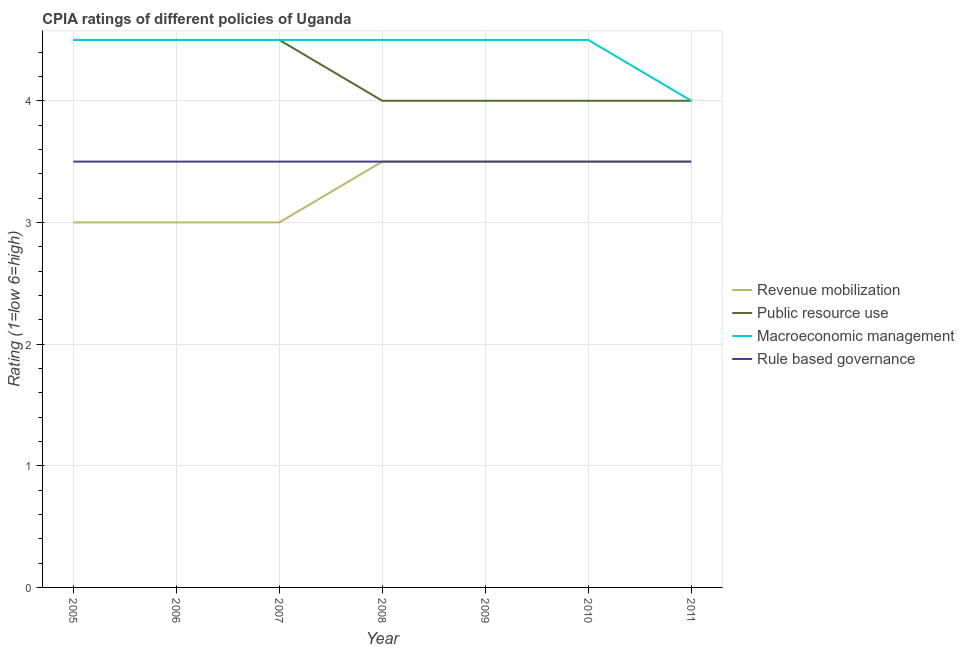How many different coloured lines are there?
Your answer should be compact. 4. Is the number of lines equal to the number of legend labels?
Your response must be concise. Yes. What is the cpia rating of revenue mobilization in 2005?
Provide a short and direct response. 3. In which year was the cpia rating of revenue mobilization minimum?
Ensure brevity in your answer.  2005. What is the total cpia rating of revenue mobilization in the graph?
Provide a succinct answer. 23. What is the difference between the cpia rating of public resource use in 2005 and that in 2008?
Offer a very short reply. 0.5. What is the difference between the cpia rating of macroeconomic management in 2005 and the cpia rating of public resource use in 2010?
Give a very brief answer. 0.5. What is the average cpia rating of macroeconomic management per year?
Provide a short and direct response. 4.43. Is the cpia rating of revenue mobilization in 2005 less than that in 2008?
Provide a short and direct response. Yes. Is the difference between the cpia rating of revenue mobilization in 2007 and 2009 greater than the difference between the cpia rating of public resource use in 2007 and 2009?
Ensure brevity in your answer.  No. Is it the case that in every year, the sum of the cpia rating of revenue mobilization and cpia rating of public resource use is greater than the cpia rating of macroeconomic management?
Offer a terse response. Yes. Does the cpia rating of revenue mobilization monotonically increase over the years?
Your answer should be compact. No. Is the cpia rating of public resource use strictly greater than the cpia rating of revenue mobilization over the years?
Provide a succinct answer. Yes. Is the cpia rating of rule based governance strictly less than the cpia rating of public resource use over the years?
Your response must be concise. Yes. How many lines are there?
Your answer should be very brief. 4. How many years are there in the graph?
Keep it short and to the point. 7. Does the graph contain any zero values?
Make the answer very short. No. How many legend labels are there?
Offer a very short reply. 4. What is the title of the graph?
Ensure brevity in your answer.  CPIA ratings of different policies of Uganda. Does "Business regulatory environment" appear as one of the legend labels in the graph?
Make the answer very short. No. What is the label or title of the Y-axis?
Your answer should be compact. Rating (1=low 6=high). What is the Rating (1=low 6=high) of Revenue mobilization in 2005?
Your response must be concise. 3. What is the Rating (1=low 6=high) of Public resource use in 2005?
Make the answer very short. 4.5. What is the Rating (1=low 6=high) of Macroeconomic management in 2005?
Your answer should be very brief. 4.5. What is the Rating (1=low 6=high) in Public resource use in 2006?
Give a very brief answer. 4.5. What is the Rating (1=low 6=high) of Macroeconomic management in 2006?
Ensure brevity in your answer.  4.5. What is the Rating (1=low 6=high) of Macroeconomic management in 2007?
Offer a very short reply. 4.5. What is the Rating (1=low 6=high) in Rule based governance in 2007?
Your response must be concise. 3.5. What is the Rating (1=low 6=high) of Revenue mobilization in 2008?
Offer a very short reply. 3.5. What is the Rating (1=low 6=high) in Macroeconomic management in 2008?
Provide a short and direct response. 4.5. What is the Rating (1=low 6=high) of Revenue mobilization in 2009?
Your response must be concise. 3.5. What is the Rating (1=low 6=high) in Revenue mobilization in 2010?
Provide a short and direct response. 3.5. What is the Rating (1=low 6=high) in Public resource use in 2010?
Provide a succinct answer. 4. What is the Rating (1=low 6=high) in Rule based governance in 2010?
Give a very brief answer. 3.5. What is the Rating (1=low 6=high) in Revenue mobilization in 2011?
Offer a very short reply. 3.5. What is the Rating (1=low 6=high) in Public resource use in 2011?
Your answer should be compact. 4. What is the Rating (1=low 6=high) of Macroeconomic management in 2011?
Ensure brevity in your answer.  4. What is the Rating (1=low 6=high) in Rule based governance in 2011?
Keep it short and to the point. 3.5. Across all years, what is the maximum Rating (1=low 6=high) of Revenue mobilization?
Provide a short and direct response. 3.5. Across all years, what is the maximum Rating (1=low 6=high) in Public resource use?
Provide a succinct answer. 4.5. Across all years, what is the maximum Rating (1=low 6=high) of Macroeconomic management?
Your answer should be compact. 4.5. What is the total Rating (1=low 6=high) of Public resource use in the graph?
Offer a terse response. 29.5. What is the total Rating (1=low 6=high) in Rule based governance in the graph?
Provide a short and direct response. 24.5. What is the difference between the Rating (1=low 6=high) in Revenue mobilization in 2005 and that in 2006?
Keep it short and to the point. 0. What is the difference between the Rating (1=low 6=high) in Macroeconomic management in 2005 and that in 2006?
Offer a terse response. 0. What is the difference between the Rating (1=low 6=high) of Revenue mobilization in 2005 and that in 2007?
Offer a terse response. 0. What is the difference between the Rating (1=low 6=high) of Public resource use in 2005 and that in 2007?
Your response must be concise. 0. What is the difference between the Rating (1=low 6=high) of Macroeconomic management in 2005 and that in 2007?
Your answer should be compact. 0. What is the difference between the Rating (1=low 6=high) in Revenue mobilization in 2005 and that in 2008?
Ensure brevity in your answer.  -0.5. What is the difference between the Rating (1=low 6=high) of Public resource use in 2005 and that in 2008?
Make the answer very short. 0.5. What is the difference between the Rating (1=low 6=high) in Macroeconomic management in 2005 and that in 2008?
Your response must be concise. 0. What is the difference between the Rating (1=low 6=high) of Rule based governance in 2005 and that in 2008?
Your response must be concise. 0. What is the difference between the Rating (1=low 6=high) of Revenue mobilization in 2005 and that in 2009?
Your answer should be compact. -0.5. What is the difference between the Rating (1=low 6=high) in Public resource use in 2005 and that in 2009?
Offer a very short reply. 0.5. What is the difference between the Rating (1=low 6=high) in Macroeconomic management in 2005 and that in 2010?
Your response must be concise. 0. What is the difference between the Rating (1=low 6=high) of Rule based governance in 2005 and that in 2010?
Provide a short and direct response. 0. What is the difference between the Rating (1=low 6=high) of Macroeconomic management in 2005 and that in 2011?
Offer a terse response. 0.5. What is the difference between the Rating (1=low 6=high) in Public resource use in 2006 and that in 2007?
Your answer should be very brief. 0. What is the difference between the Rating (1=low 6=high) in Macroeconomic management in 2006 and that in 2007?
Make the answer very short. 0. What is the difference between the Rating (1=low 6=high) of Rule based governance in 2006 and that in 2007?
Keep it short and to the point. 0. What is the difference between the Rating (1=low 6=high) in Revenue mobilization in 2006 and that in 2008?
Provide a short and direct response. -0.5. What is the difference between the Rating (1=low 6=high) of Public resource use in 2006 and that in 2008?
Give a very brief answer. 0.5. What is the difference between the Rating (1=low 6=high) of Rule based governance in 2006 and that in 2008?
Your response must be concise. 0. What is the difference between the Rating (1=low 6=high) in Revenue mobilization in 2006 and that in 2009?
Provide a succinct answer. -0.5. What is the difference between the Rating (1=low 6=high) of Rule based governance in 2006 and that in 2010?
Provide a succinct answer. 0. What is the difference between the Rating (1=low 6=high) in Revenue mobilization in 2006 and that in 2011?
Ensure brevity in your answer.  -0.5. What is the difference between the Rating (1=low 6=high) of Macroeconomic management in 2007 and that in 2008?
Offer a very short reply. 0. What is the difference between the Rating (1=low 6=high) in Rule based governance in 2007 and that in 2008?
Your answer should be very brief. 0. What is the difference between the Rating (1=low 6=high) of Revenue mobilization in 2007 and that in 2010?
Make the answer very short. -0.5. What is the difference between the Rating (1=low 6=high) in Macroeconomic management in 2007 and that in 2010?
Ensure brevity in your answer.  0. What is the difference between the Rating (1=low 6=high) of Rule based governance in 2007 and that in 2010?
Provide a short and direct response. 0. What is the difference between the Rating (1=low 6=high) in Public resource use in 2007 and that in 2011?
Your response must be concise. 0.5. What is the difference between the Rating (1=low 6=high) in Revenue mobilization in 2008 and that in 2009?
Give a very brief answer. 0. What is the difference between the Rating (1=low 6=high) of Public resource use in 2008 and that in 2009?
Your answer should be very brief. 0. What is the difference between the Rating (1=low 6=high) of Revenue mobilization in 2008 and that in 2010?
Provide a short and direct response. 0. What is the difference between the Rating (1=low 6=high) of Public resource use in 2008 and that in 2010?
Keep it short and to the point. 0. What is the difference between the Rating (1=low 6=high) of Rule based governance in 2008 and that in 2010?
Your answer should be very brief. 0. What is the difference between the Rating (1=low 6=high) in Public resource use in 2009 and that in 2010?
Your response must be concise. 0. What is the difference between the Rating (1=low 6=high) in Macroeconomic management in 2009 and that in 2010?
Keep it short and to the point. 0. What is the difference between the Rating (1=low 6=high) in Rule based governance in 2009 and that in 2011?
Provide a succinct answer. 0. What is the difference between the Rating (1=low 6=high) in Rule based governance in 2010 and that in 2011?
Ensure brevity in your answer.  0. What is the difference between the Rating (1=low 6=high) of Revenue mobilization in 2005 and the Rating (1=low 6=high) of Macroeconomic management in 2006?
Provide a succinct answer. -1.5. What is the difference between the Rating (1=low 6=high) in Public resource use in 2005 and the Rating (1=low 6=high) in Rule based governance in 2006?
Provide a short and direct response. 1. What is the difference between the Rating (1=low 6=high) of Public resource use in 2005 and the Rating (1=low 6=high) of Rule based governance in 2007?
Offer a very short reply. 1. What is the difference between the Rating (1=low 6=high) in Revenue mobilization in 2005 and the Rating (1=low 6=high) in Public resource use in 2008?
Provide a succinct answer. -1. What is the difference between the Rating (1=low 6=high) of Revenue mobilization in 2005 and the Rating (1=low 6=high) of Macroeconomic management in 2008?
Offer a very short reply. -1.5. What is the difference between the Rating (1=low 6=high) in Public resource use in 2005 and the Rating (1=low 6=high) in Rule based governance in 2008?
Give a very brief answer. 1. What is the difference between the Rating (1=low 6=high) of Revenue mobilization in 2005 and the Rating (1=low 6=high) of Rule based governance in 2009?
Offer a terse response. -0.5. What is the difference between the Rating (1=low 6=high) of Public resource use in 2005 and the Rating (1=low 6=high) of Rule based governance in 2009?
Give a very brief answer. 1. What is the difference between the Rating (1=low 6=high) of Macroeconomic management in 2005 and the Rating (1=low 6=high) of Rule based governance in 2009?
Your answer should be very brief. 1. What is the difference between the Rating (1=low 6=high) of Revenue mobilization in 2005 and the Rating (1=low 6=high) of Public resource use in 2010?
Provide a succinct answer. -1. What is the difference between the Rating (1=low 6=high) in Public resource use in 2005 and the Rating (1=low 6=high) in Rule based governance in 2010?
Your answer should be very brief. 1. What is the difference between the Rating (1=low 6=high) in Revenue mobilization in 2005 and the Rating (1=low 6=high) in Public resource use in 2011?
Provide a short and direct response. -1. What is the difference between the Rating (1=low 6=high) in Revenue mobilization in 2005 and the Rating (1=low 6=high) in Macroeconomic management in 2011?
Give a very brief answer. -1. What is the difference between the Rating (1=low 6=high) in Revenue mobilization in 2005 and the Rating (1=low 6=high) in Rule based governance in 2011?
Make the answer very short. -0.5. What is the difference between the Rating (1=low 6=high) of Public resource use in 2005 and the Rating (1=low 6=high) of Macroeconomic management in 2011?
Your answer should be compact. 0.5. What is the difference between the Rating (1=low 6=high) in Public resource use in 2005 and the Rating (1=low 6=high) in Rule based governance in 2011?
Your answer should be compact. 1. What is the difference between the Rating (1=low 6=high) in Macroeconomic management in 2006 and the Rating (1=low 6=high) in Rule based governance in 2007?
Offer a very short reply. 1. What is the difference between the Rating (1=low 6=high) of Revenue mobilization in 2006 and the Rating (1=low 6=high) of Public resource use in 2008?
Your answer should be very brief. -1. What is the difference between the Rating (1=low 6=high) of Revenue mobilization in 2006 and the Rating (1=low 6=high) of Macroeconomic management in 2008?
Offer a terse response. -1.5. What is the difference between the Rating (1=low 6=high) of Revenue mobilization in 2006 and the Rating (1=low 6=high) of Rule based governance in 2008?
Offer a terse response. -0.5. What is the difference between the Rating (1=low 6=high) in Macroeconomic management in 2006 and the Rating (1=low 6=high) in Rule based governance in 2008?
Give a very brief answer. 1. What is the difference between the Rating (1=low 6=high) of Revenue mobilization in 2006 and the Rating (1=low 6=high) of Rule based governance in 2009?
Make the answer very short. -0.5. What is the difference between the Rating (1=low 6=high) in Public resource use in 2006 and the Rating (1=low 6=high) in Macroeconomic management in 2009?
Offer a terse response. 0. What is the difference between the Rating (1=low 6=high) of Revenue mobilization in 2006 and the Rating (1=low 6=high) of Public resource use in 2010?
Give a very brief answer. -1. What is the difference between the Rating (1=low 6=high) of Macroeconomic management in 2006 and the Rating (1=low 6=high) of Rule based governance in 2010?
Your answer should be very brief. 1. What is the difference between the Rating (1=low 6=high) in Public resource use in 2006 and the Rating (1=low 6=high) in Rule based governance in 2011?
Keep it short and to the point. 1. What is the difference between the Rating (1=low 6=high) of Macroeconomic management in 2006 and the Rating (1=low 6=high) of Rule based governance in 2011?
Provide a short and direct response. 1. What is the difference between the Rating (1=low 6=high) of Revenue mobilization in 2007 and the Rating (1=low 6=high) of Macroeconomic management in 2008?
Offer a very short reply. -1.5. What is the difference between the Rating (1=low 6=high) in Revenue mobilization in 2007 and the Rating (1=low 6=high) in Rule based governance in 2008?
Make the answer very short. -0.5. What is the difference between the Rating (1=low 6=high) in Public resource use in 2007 and the Rating (1=low 6=high) in Macroeconomic management in 2008?
Ensure brevity in your answer.  0. What is the difference between the Rating (1=low 6=high) in Public resource use in 2007 and the Rating (1=low 6=high) in Rule based governance in 2008?
Offer a very short reply. 1. What is the difference between the Rating (1=low 6=high) in Macroeconomic management in 2007 and the Rating (1=low 6=high) in Rule based governance in 2008?
Provide a succinct answer. 1. What is the difference between the Rating (1=low 6=high) of Revenue mobilization in 2007 and the Rating (1=low 6=high) of Macroeconomic management in 2009?
Offer a very short reply. -1.5. What is the difference between the Rating (1=low 6=high) in Public resource use in 2007 and the Rating (1=low 6=high) in Rule based governance in 2009?
Give a very brief answer. 1. What is the difference between the Rating (1=low 6=high) of Macroeconomic management in 2007 and the Rating (1=low 6=high) of Rule based governance in 2009?
Keep it short and to the point. 1. What is the difference between the Rating (1=low 6=high) of Revenue mobilization in 2007 and the Rating (1=low 6=high) of Macroeconomic management in 2010?
Your answer should be compact. -1.5. What is the difference between the Rating (1=low 6=high) in Public resource use in 2007 and the Rating (1=low 6=high) in Macroeconomic management in 2010?
Offer a very short reply. 0. What is the difference between the Rating (1=low 6=high) in Macroeconomic management in 2007 and the Rating (1=low 6=high) in Rule based governance in 2010?
Your answer should be very brief. 1. What is the difference between the Rating (1=low 6=high) in Revenue mobilization in 2007 and the Rating (1=low 6=high) in Public resource use in 2011?
Offer a terse response. -1. What is the difference between the Rating (1=low 6=high) of Revenue mobilization in 2007 and the Rating (1=low 6=high) of Macroeconomic management in 2011?
Keep it short and to the point. -1. What is the difference between the Rating (1=low 6=high) of Revenue mobilization in 2007 and the Rating (1=low 6=high) of Rule based governance in 2011?
Provide a succinct answer. -0.5. What is the difference between the Rating (1=low 6=high) of Public resource use in 2007 and the Rating (1=low 6=high) of Macroeconomic management in 2011?
Provide a short and direct response. 0.5. What is the difference between the Rating (1=low 6=high) of Macroeconomic management in 2007 and the Rating (1=low 6=high) of Rule based governance in 2011?
Give a very brief answer. 1. What is the difference between the Rating (1=low 6=high) of Public resource use in 2008 and the Rating (1=low 6=high) of Rule based governance in 2009?
Your response must be concise. 0.5. What is the difference between the Rating (1=low 6=high) in Macroeconomic management in 2008 and the Rating (1=low 6=high) in Rule based governance in 2009?
Make the answer very short. 1. What is the difference between the Rating (1=low 6=high) in Revenue mobilization in 2008 and the Rating (1=low 6=high) in Public resource use in 2010?
Provide a short and direct response. -0.5. What is the difference between the Rating (1=low 6=high) in Public resource use in 2008 and the Rating (1=low 6=high) in Macroeconomic management in 2010?
Make the answer very short. -0.5. What is the difference between the Rating (1=low 6=high) of Revenue mobilization in 2008 and the Rating (1=low 6=high) of Public resource use in 2011?
Ensure brevity in your answer.  -0.5. What is the difference between the Rating (1=low 6=high) of Public resource use in 2008 and the Rating (1=low 6=high) of Macroeconomic management in 2011?
Keep it short and to the point. 0. What is the difference between the Rating (1=low 6=high) of Macroeconomic management in 2008 and the Rating (1=low 6=high) of Rule based governance in 2011?
Your response must be concise. 1. What is the difference between the Rating (1=low 6=high) in Public resource use in 2009 and the Rating (1=low 6=high) in Macroeconomic management in 2010?
Keep it short and to the point. -0.5. What is the difference between the Rating (1=low 6=high) in Macroeconomic management in 2009 and the Rating (1=low 6=high) in Rule based governance in 2010?
Provide a short and direct response. 1. What is the difference between the Rating (1=low 6=high) in Revenue mobilization in 2009 and the Rating (1=low 6=high) in Macroeconomic management in 2011?
Offer a terse response. -0.5. What is the difference between the Rating (1=low 6=high) in Revenue mobilization in 2009 and the Rating (1=low 6=high) in Rule based governance in 2011?
Provide a short and direct response. 0. What is the difference between the Rating (1=low 6=high) in Revenue mobilization in 2010 and the Rating (1=low 6=high) in Macroeconomic management in 2011?
Offer a very short reply. -0.5. What is the difference between the Rating (1=low 6=high) of Public resource use in 2010 and the Rating (1=low 6=high) of Macroeconomic management in 2011?
Your response must be concise. 0. What is the average Rating (1=low 6=high) of Revenue mobilization per year?
Your response must be concise. 3.29. What is the average Rating (1=low 6=high) of Public resource use per year?
Provide a succinct answer. 4.21. What is the average Rating (1=low 6=high) in Macroeconomic management per year?
Offer a terse response. 4.43. In the year 2005, what is the difference between the Rating (1=low 6=high) of Revenue mobilization and Rating (1=low 6=high) of Public resource use?
Offer a very short reply. -1.5. In the year 2005, what is the difference between the Rating (1=low 6=high) of Revenue mobilization and Rating (1=low 6=high) of Macroeconomic management?
Provide a succinct answer. -1.5. In the year 2005, what is the difference between the Rating (1=low 6=high) of Revenue mobilization and Rating (1=low 6=high) of Rule based governance?
Your answer should be compact. -0.5. In the year 2005, what is the difference between the Rating (1=low 6=high) in Public resource use and Rating (1=low 6=high) in Macroeconomic management?
Provide a short and direct response. 0. In the year 2005, what is the difference between the Rating (1=low 6=high) in Macroeconomic management and Rating (1=low 6=high) in Rule based governance?
Provide a succinct answer. 1. In the year 2006, what is the difference between the Rating (1=low 6=high) in Revenue mobilization and Rating (1=low 6=high) in Macroeconomic management?
Make the answer very short. -1.5. In the year 2006, what is the difference between the Rating (1=low 6=high) in Revenue mobilization and Rating (1=low 6=high) in Rule based governance?
Your answer should be very brief. -0.5. In the year 2006, what is the difference between the Rating (1=low 6=high) in Public resource use and Rating (1=low 6=high) in Macroeconomic management?
Your answer should be very brief. 0. In the year 2006, what is the difference between the Rating (1=low 6=high) in Public resource use and Rating (1=low 6=high) in Rule based governance?
Make the answer very short. 1. In the year 2006, what is the difference between the Rating (1=low 6=high) in Macroeconomic management and Rating (1=low 6=high) in Rule based governance?
Keep it short and to the point. 1. In the year 2007, what is the difference between the Rating (1=low 6=high) in Revenue mobilization and Rating (1=low 6=high) in Macroeconomic management?
Your response must be concise. -1.5. In the year 2007, what is the difference between the Rating (1=low 6=high) of Revenue mobilization and Rating (1=low 6=high) of Rule based governance?
Your response must be concise. -0.5. In the year 2008, what is the difference between the Rating (1=low 6=high) of Revenue mobilization and Rating (1=low 6=high) of Macroeconomic management?
Provide a short and direct response. -1. In the year 2008, what is the difference between the Rating (1=low 6=high) of Public resource use and Rating (1=low 6=high) of Macroeconomic management?
Keep it short and to the point. -0.5. In the year 2008, what is the difference between the Rating (1=low 6=high) of Macroeconomic management and Rating (1=low 6=high) of Rule based governance?
Provide a succinct answer. 1. In the year 2009, what is the difference between the Rating (1=low 6=high) in Revenue mobilization and Rating (1=low 6=high) in Rule based governance?
Offer a very short reply. 0. In the year 2009, what is the difference between the Rating (1=low 6=high) in Public resource use and Rating (1=low 6=high) in Macroeconomic management?
Provide a succinct answer. -0.5. In the year 2010, what is the difference between the Rating (1=low 6=high) of Revenue mobilization and Rating (1=low 6=high) of Public resource use?
Your answer should be very brief. -0.5. In the year 2010, what is the difference between the Rating (1=low 6=high) of Public resource use and Rating (1=low 6=high) of Macroeconomic management?
Your answer should be very brief. -0.5. In the year 2011, what is the difference between the Rating (1=low 6=high) in Revenue mobilization and Rating (1=low 6=high) in Rule based governance?
Give a very brief answer. 0. In the year 2011, what is the difference between the Rating (1=low 6=high) in Public resource use and Rating (1=low 6=high) in Macroeconomic management?
Your answer should be very brief. 0. What is the ratio of the Rating (1=low 6=high) of Revenue mobilization in 2005 to that in 2006?
Offer a very short reply. 1. What is the ratio of the Rating (1=low 6=high) in Public resource use in 2005 to that in 2006?
Offer a very short reply. 1. What is the ratio of the Rating (1=low 6=high) in Macroeconomic management in 2005 to that in 2006?
Your response must be concise. 1. What is the ratio of the Rating (1=low 6=high) in Rule based governance in 2005 to that in 2006?
Keep it short and to the point. 1. What is the ratio of the Rating (1=low 6=high) in Public resource use in 2005 to that in 2007?
Offer a terse response. 1. What is the ratio of the Rating (1=low 6=high) in Rule based governance in 2005 to that in 2007?
Your answer should be very brief. 1. What is the ratio of the Rating (1=low 6=high) in Revenue mobilization in 2005 to that in 2008?
Make the answer very short. 0.86. What is the ratio of the Rating (1=low 6=high) of Macroeconomic management in 2005 to that in 2008?
Provide a short and direct response. 1. What is the ratio of the Rating (1=low 6=high) in Public resource use in 2005 to that in 2009?
Provide a short and direct response. 1.12. What is the ratio of the Rating (1=low 6=high) in Macroeconomic management in 2005 to that in 2009?
Make the answer very short. 1. What is the ratio of the Rating (1=low 6=high) in Rule based governance in 2005 to that in 2009?
Keep it short and to the point. 1. What is the ratio of the Rating (1=low 6=high) of Public resource use in 2005 to that in 2010?
Your response must be concise. 1.12. What is the ratio of the Rating (1=low 6=high) in Macroeconomic management in 2005 to that in 2010?
Your answer should be very brief. 1. What is the ratio of the Rating (1=low 6=high) of Rule based governance in 2005 to that in 2010?
Your response must be concise. 1. What is the ratio of the Rating (1=low 6=high) of Revenue mobilization in 2005 to that in 2011?
Offer a very short reply. 0.86. What is the ratio of the Rating (1=low 6=high) in Macroeconomic management in 2005 to that in 2011?
Keep it short and to the point. 1.12. What is the ratio of the Rating (1=low 6=high) in Revenue mobilization in 2006 to that in 2007?
Offer a terse response. 1. What is the ratio of the Rating (1=low 6=high) in Macroeconomic management in 2006 to that in 2008?
Offer a terse response. 1. What is the ratio of the Rating (1=low 6=high) of Rule based governance in 2006 to that in 2008?
Your answer should be very brief. 1. What is the ratio of the Rating (1=low 6=high) in Macroeconomic management in 2006 to that in 2009?
Your answer should be very brief. 1. What is the ratio of the Rating (1=low 6=high) in Rule based governance in 2006 to that in 2009?
Keep it short and to the point. 1. What is the ratio of the Rating (1=low 6=high) in Public resource use in 2006 to that in 2010?
Make the answer very short. 1.12. What is the ratio of the Rating (1=low 6=high) in Macroeconomic management in 2006 to that in 2010?
Ensure brevity in your answer.  1. What is the ratio of the Rating (1=low 6=high) in Rule based governance in 2006 to that in 2010?
Offer a terse response. 1. What is the ratio of the Rating (1=low 6=high) in Revenue mobilization in 2006 to that in 2011?
Offer a very short reply. 0.86. What is the ratio of the Rating (1=low 6=high) of Rule based governance in 2006 to that in 2011?
Offer a terse response. 1. What is the ratio of the Rating (1=low 6=high) in Revenue mobilization in 2007 to that in 2008?
Your answer should be compact. 0.86. What is the ratio of the Rating (1=low 6=high) of Public resource use in 2007 to that in 2009?
Your answer should be compact. 1.12. What is the ratio of the Rating (1=low 6=high) of Rule based governance in 2007 to that in 2009?
Offer a terse response. 1. What is the ratio of the Rating (1=low 6=high) of Revenue mobilization in 2007 to that in 2010?
Give a very brief answer. 0.86. What is the ratio of the Rating (1=low 6=high) in Public resource use in 2007 to that in 2011?
Ensure brevity in your answer.  1.12. What is the ratio of the Rating (1=low 6=high) of Macroeconomic management in 2007 to that in 2011?
Make the answer very short. 1.12. What is the ratio of the Rating (1=low 6=high) in Revenue mobilization in 2008 to that in 2009?
Your answer should be very brief. 1. What is the ratio of the Rating (1=low 6=high) of Rule based governance in 2008 to that in 2009?
Offer a very short reply. 1. What is the ratio of the Rating (1=low 6=high) in Public resource use in 2008 to that in 2010?
Your answer should be very brief. 1. What is the ratio of the Rating (1=low 6=high) in Revenue mobilization in 2008 to that in 2011?
Provide a short and direct response. 1. What is the ratio of the Rating (1=low 6=high) of Public resource use in 2008 to that in 2011?
Ensure brevity in your answer.  1. What is the ratio of the Rating (1=low 6=high) in Rule based governance in 2008 to that in 2011?
Provide a short and direct response. 1. What is the ratio of the Rating (1=low 6=high) of Public resource use in 2009 to that in 2010?
Give a very brief answer. 1. What is the ratio of the Rating (1=low 6=high) in Macroeconomic management in 2009 to that in 2010?
Offer a very short reply. 1. What is the ratio of the Rating (1=low 6=high) of Rule based governance in 2009 to that in 2010?
Your answer should be compact. 1. What is the ratio of the Rating (1=low 6=high) of Revenue mobilization in 2009 to that in 2011?
Offer a terse response. 1. What is the ratio of the Rating (1=low 6=high) of Public resource use in 2009 to that in 2011?
Give a very brief answer. 1. What is the ratio of the Rating (1=low 6=high) in Revenue mobilization in 2010 to that in 2011?
Your answer should be compact. 1. What is the ratio of the Rating (1=low 6=high) of Public resource use in 2010 to that in 2011?
Give a very brief answer. 1. What is the difference between the highest and the second highest Rating (1=low 6=high) of Public resource use?
Provide a short and direct response. 0. What is the difference between the highest and the second highest Rating (1=low 6=high) of Macroeconomic management?
Offer a terse response. 0. What is the difference between the highest and the second highest Rating (1=low 6=high) in Rule based governance?
Ensure brevity in your answer.  0. What is the difference between the highest and the lowest Rating (1=low 6=high) in Revenue mobilization?
Your answer should be very brief. 0.5. What is the difference between the highest and the lowest Rating (1=low 6=high) in Macroeconomic management?
Your answer should be compact. 0.5. What is the difference between the highest and the lowest Rating (1=low 6=high) of Rule based governance?
Ensure brevity in your answer.  0. 